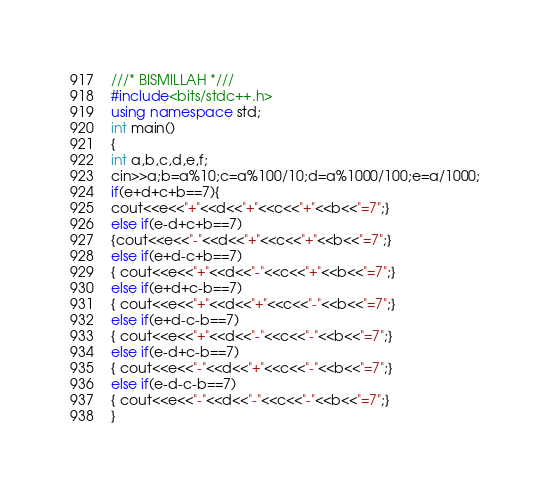Convert code to text. <code><loc_0><loc_0><loc_500><loc_500><_C++_>///* BISMILLAH *///
#include<bits/stdc++.h>
using namespace std;
int main()
{
int a,b,c,d,e,f;
cin>>a;b=a%10;c=a%100/10;d=a%1000/100;e=a/1000;
if(e+d+c+b==7){
cout<<e<<"+"<<d<<"+"<<c<<"+"<<b<<"=7";}
else if(e-d+c+b==7)
{cout<<e<<"-"<<d<<"+"<<c<<"+"<<b<<"=7";}
else if(e+d-c+b==7)
{ cout<<e<<"+"<<d<<"-"<<c<<"+"<<b<<"=7";}
else if(e+d+c-b==7)
{ cout<<e<<"+"<<d<<"+"<<c<<"-"<<b<<"=7";}
else if(e+d-c-b==7)
{ cout<<e<<"+"<<d<<"-"<<c<<"-"<<b<<"=7";}
else if(e-d+c-b==7)
{ cout<<e<<"-"<<d<<"+"<<c<<"-"<<b<<"=7";}
else if(e-d-c-b==7)
{ cout<<e<<"-"<<d<<"-"<<c<<"-"<<b<<"=7";}
}</code> 